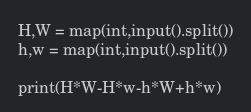Convert code to text. <code><loc_0><loc_0><loc_500><loc_500><_Python_>H,W = map(int,input().split())
h,w = map(int,input().split())

print(H*W-H*w-h*W+h*w)</code> 